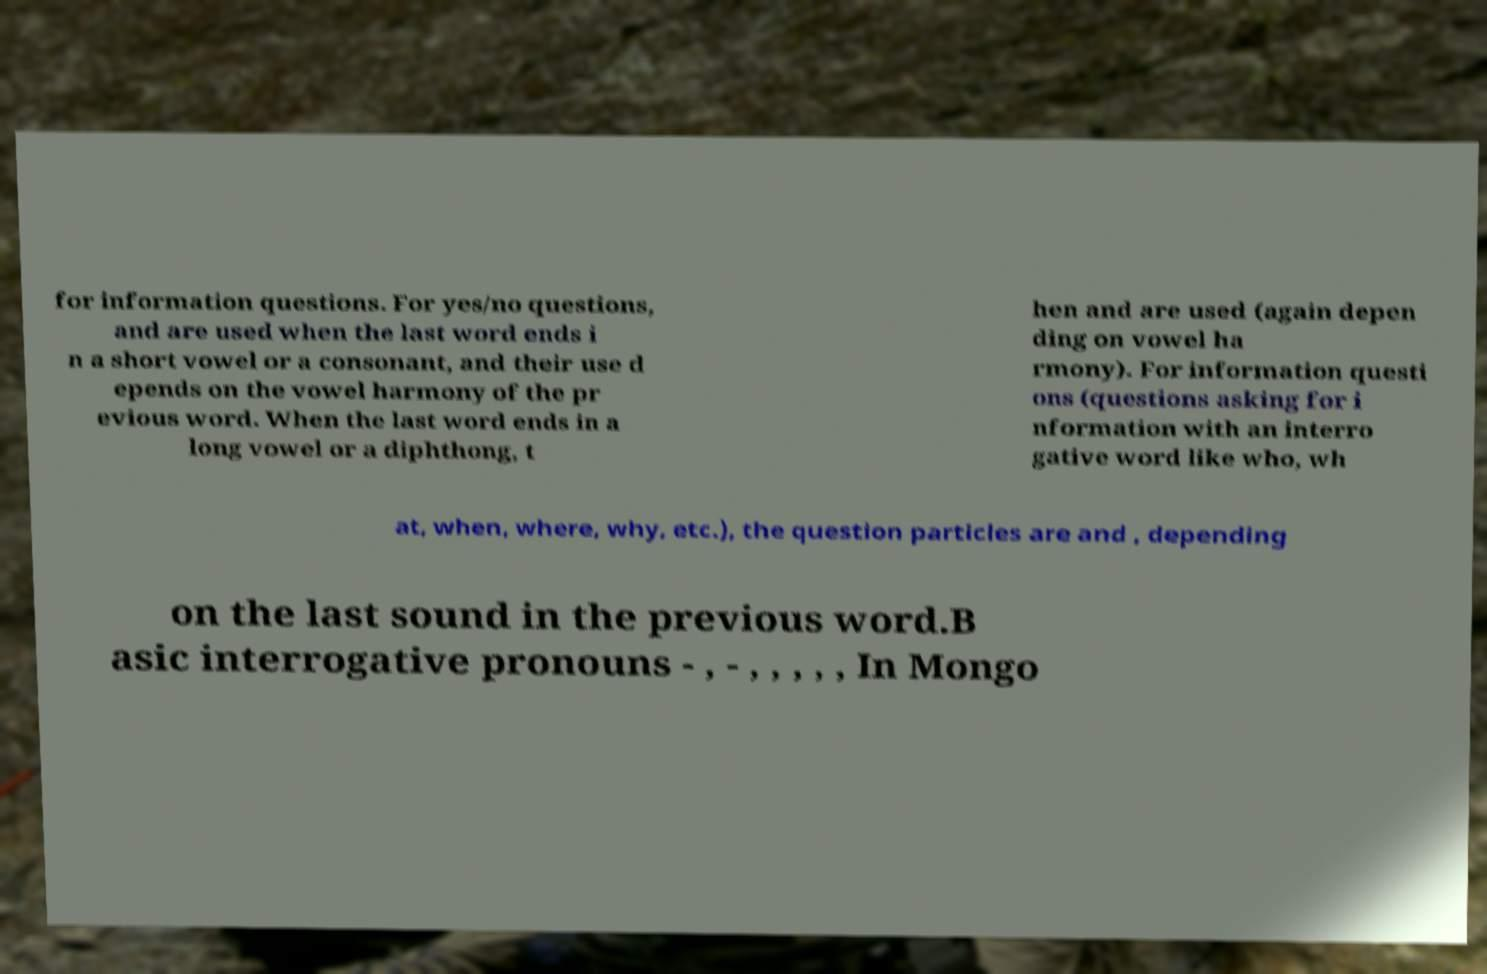Please read and relay the text visible in this image. What does it say? for information questions. For yes/no questions, and are used when the last word ends i n a short vowel or a consonant, and their use d epends on the vowel harmony of the pr evious word. When the last word ends in a long vowel or a diphthong, t hen and are used (again depen ding on vowel ha rmony). For information questi ons (questions asking for i nformation with an interro gative word like who, wh at, when, where, why, etc.), the question particles are and , depending on the last sound in the previous word.B asic interrogative pronouns - , - , , , , , In Mongo 